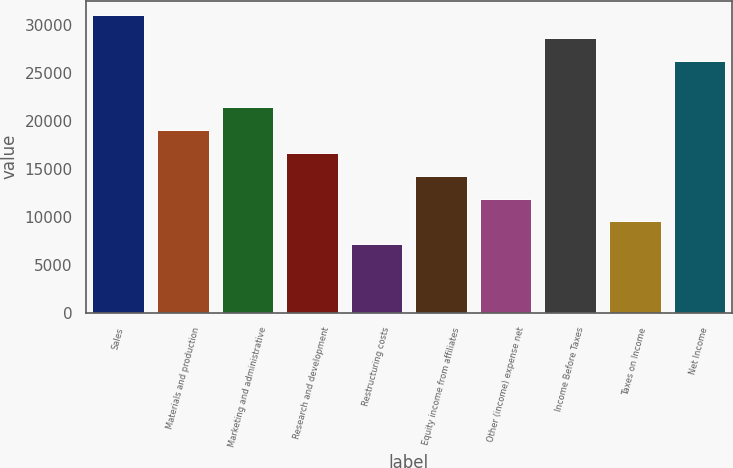Convert chart to OTSL. <chart><loc_0><loc_0><loc_500><loc_500><bar_chart><fcel>Sales<fcel>Materials and production<fcel>Marketing and administrative<fcel>Research and development<fcel>Restructuring costs<fcel>Equity income from affiliates<fcel>Other (income) expense net<fcel>Income Before Taxes<fcel>Taxes on Income<fcel>Net Income<nl><fcel>31004<fcel>19080.8<fcel>21465.4<fcel>16696.1<fcel>7157.55<fcel>14311.5<fcel>11926.8<fcel>28619.3<fcel>9542.19<fcel>26234.7<nl></chart> 